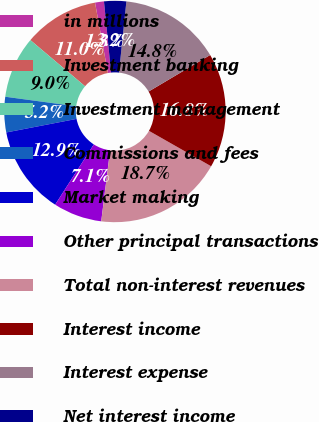Convert chart. <chart><loc_0><loc_0><loc_500><loc_500><pie_chart><fcel>in millions<fcel>Investment banking<fcel>Investment management<fcel>Commissions and fees<fcel>Market making<fcel>Other principal transactions<fcel>Total non-interest revenues<fcel>Interest income<fcel>Interest expense<fcel>Net interest income<nl><fcel>1.3%<fcel>10.96%<fcel>9.03%<fcel>5.16%<fcel>12.89%<fcel>7.1%<fcel>18.74%<fcel>16.76%<fcel>14.83%<fcel>3.23%<nl></chart> 